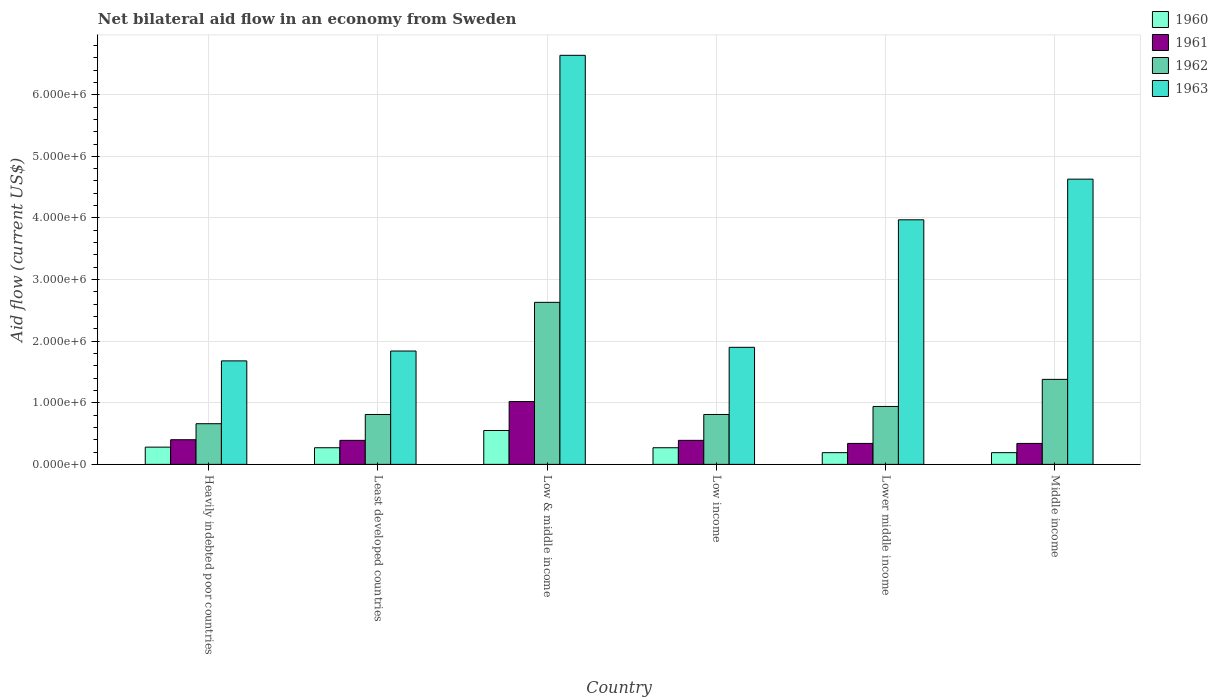How many groups of bars are there?
Ensure brevity in your answer.  6. Are the number of bars per tick equal to the number of legend labels?
Your response must be concise. Yes. How many bars are there on the 2nd tick from the left?
Keep it short and to the point. 4. What is the label of the 5th group of bars from the left?
Your response must be concise. Lower middle income. What is the net bilateral aid flow in 1962 in Low income?
Provide a succinct answer. 8.10e+05. Across all countries, what is the maximum net bilateral aid flow in 1960?
Your answer should be very brief. 5.50e+05. Across all countries, what is the minimum net bilateral aid flow in 1963?
Make the answer very short. 1.68e+06. In which country was the net bilateral aid flow in 1963 maximum?
Offer a terse response. Low & middle income. In which country was the net bilateral aid flow in 1963 minimum?
Your answer should be compact. Heavily indebted poor countries. What is the total net bilateral aid flow in 1961 in the graph?
Keep it short and to the point. 2.88e+06. What is the difference between the net bilateral aid flow in 1962 in Heavily indebted poor countries and the net bilateral aid flow in 1963 in Lower middle income?
Give a very brief answer. -3.31e+06. What is the average net bilateral aid flow in 1960 per country?
Your answer should be very brief. 2.92e+05. What is the difference between the net bilateral aid flow of/in 1962 and net bilateral aid flow of/in 1963 in Heavily indebted poor countries?
Provide a succinct answer. -1.02e+06. In how many countries, is the net bilateral aid flow in 1962 greater than 2000000 US$?
Provide a short and direct response. 1. What is the ratio of the net bilateral aid flow in 1963 in Least developed countries to that in Lower middle income?
Offer a very short reply. 0.46. What is the difference between the highest and the second highest net bilateral aid flow in 1963?
Make the answer very short. 2.01e+06. What is the difference between the highest and the lowest net bilateral aid flow in 1962?
Make the answer very short. 1.97e+06. In how many countries, is the net bilateral aid flow in 1962 greater than the average net bilateral aid flow in 1962 taken over all countries?
Make the answer very short. 2. Is the sum of the net bilateral aid flow in 1962 in Heavily indebted poor countries and Least developed countries greater than the maximum net bilateral aid flow in 1960 across all countries?
Offer a very short reply. Yes. Is it the case that in every country, the sum of the net bilateral aid flow in 1961 and net bilateral aid flow in 1962 is greater than the sum of net bilateral aid flow in 1960 and net bilateral aid flow in 1963?
Offer a terse response. No. What does the 1st bar from the right in Low & middle income represents?
Give a very brief answer. 1963. Is it the case that in every country, the sum of the net bilateral aid flow in 1961 and net bilateral aid flow in 1962 is greater than the net bilateral aid flow in 1960?
Offer a very short reply. Yes. Are all the bars in the graph horizontal?
Your answer should be very brief. No. How many countries are there in the graph?
Provide a succinct answer. 6. Does the graph contain any zero values?
Provide a succinct answer. No. Does the graph contain grids?
Offer a very short reply. Yes. How are the legend labels stacked?
Offer a very short reply. Vertical. What is the title of the graph?
Your answer should be compact. Net bilateral aid flow in an economy from Sweden. Does "1972" appear as one of the legend labels in the graph?
Offer a terse response. No. What is the label or title of the Y-axis?
Make the answer very short. Aid flow (current US$). What is the Aid flow (current US$) in 1961 in Heavily indebted poor countries?
Offer a terse response. 4.00e+05. What is the Aid flow (current US$) of 1962 in Heavily indebted poor countries?
Offer a terse response. 6.60e+05. What is the Aid flow (current US$) in 1963 in Heavily indebted poor countries?
Make the answer very short. 1.68e+06. What is the Aid flow (current US$) of 1961 in Least developed countries?
Offer a terse response. 3.90e+05. What is the Aid flow (current US$) of 1962 in Least developed countries?
Your answer should be compact. 8.10e+05. What is the Aid flow (current US$) in 1963 in Least developed countries?
Offer a very short reply. 1.84e+06. What is the Aid flow (current US$) of 1960 in Low & middle income?
Offer a very short reply. 5.50e+05. What is the Aid flow (current US$) in 1961 in Low & middle income?
Your answer should be very brief. 1.02e+06. What is the Aid flow (current US$) of 1962 in Low & middle income?
Your answer should be compact. 2.63e+06. What is the Aid flow (current US$) in 1963 in Low & middle income?
Your answer should be very brief. 6.64e+06. What is the Aid flow (current US$) in 1960 in Low income?
Provide a short and direct response. 2.70e+05. What is the Aid flow (current US$) of 1961 in Low income?
Offer a very short reply. 3.90e+05. What is the Aid flow (current US$) in 1962 in Low income?
Give a very brief answer. 8.10e+05. What is the Aid flow (current US$) of 1963 in Low income?
Keep it short and to the point. 1.90e+06. What is the Aid flow (current US$) of 1962 in Lower middle income?
Provide a short and direct response. 9.40e+05. What is the Aid flow (current US$) in 1963 in Lower middle income?
Offer a terse response. 3.97e+06. What is the Aid flow (current US$) of 1960 in Middle income?
Your answer should be compact. 1.90e+05. What is the Aid flow (current US$) in 1962 in Middle income?
Your response must be concise. 1.38e+06. What is the Aid flow (current US$) in 1963 in Middle income?
Ensure brevity in your answer.  4.63e+06. Across all countries, what is the maximum Aid flow (current US$) in 1960?
Your answer should be very brief. 5.50e+05. Across all countries, what is the maximum Aid flow (current US$) of 1961?
Give a very brief answer. 1.02e+06. Across all countries, what is the maximum Aid flow (current US$) of 1962?
Your response must be concise. 2.63e+06. Across all countries, what is the maximum Aid flow (current US$) of 1963?
Keep it short and to the point. 6.64e+06. Across all countries, what is the minimum Aid flow (current US$) of 1961?
Your answer should be compact. 3.40e+05. Across all countries, what is the minimum Aid flow (current US$) of 1963?
Your answer should be compact. 1.68e+06. What is the total Aid flow (current US$) of 1960 in the graph?
Make the answer very short. 1.75e+06. What is the total Aid flow (current US$) of 1961 in the graph?
Give a very brief answer. 2.88e+06. What is the total Aid flow (current US$) of 1962 in the graph?
Give a very brief answer. 7.23e+06. What is the total Aid flow (current US$) of 1963 in the graph?
Ensure brevity in your answer.  2.07e+07. What is the difference between the Aid flow (current US$) in 1961 in Heavily indebted poor countries and that in Low & middle income?
Ensure brevity in your answer.  -6.20e+05. What is the difference between the Aid flow (current US$) in 1962 in Heavily indebted poor countries and that in Low & middle income?
Your answer should be compact. -1.97e+06. What is the difference between the Aid flow (current US$) of 1963 in Heavily indebted poor countries and that in Low & middle income?
Your response must be concise. -4.96e+06. What is the difference between the Aid flow (current US$) of 1960 in Heavily indebted poor countries and that in Low income?
Your answer should be very brief. 10000. What is the difference between the Aid flow (current US$) of 1962 in Heavily indebted poor countries and that in Low income?
Provide a short and direct response. -1.50e+05. What is the difference between the Aid flow (current US$) in 1960 in Heavily indebted poor countries and that in Lower middle income?
Your answer should be compact. 9.00e+04. What is the difference between the Aid flow (current US$) of 1961 in Heavily indebted poor countries and that in Lower middle income?
Keep it short and to the point. 6.00e+04. What is the difference between the Aid flow (current US$) of 1962 in Heavily indebted poor countries and that in Lower middle income?
Give a very brief answer. -2.80e+05. What is the difference between the Aid flow (current US$) in 1963 in Heavily indebted poor countries and that in Lower middle income?
Your response must be concise. -2.29e+06. What is the difference between the Aid flow (current US$) of 1962 in Heavily indebted poor countries and that in Middle income?
Ensure brevity in your answer.  -7.20e+05. What is the difference between the Aid flow (current US$) of 1963 in Heavily indebted poor countries and that in Middle income?
Your answer should be compact. -2.95e+06. What is the difference between the Aid flow (current US$) in 1960 in Least developed countries and that in Low & middle income?
Make the answer very short. -2.80e+05. What is the difference between the Aid flow (current US$) in 1961 in Least developed countries and that in Low & middle income?
Keep it short and to the point. -6.30e+05. What is the difference between the Aid flow (current US$) of 1962 in Least developed countries and that in Low & middle income?
Your answer should be very brief. -1.82e+06. What is the difference between the Aid flow (current US$) of 1963 in Least developed countries and that in Low & middle income?
Your answer should be very brief. -4.80e+06. What is the difference between the Aid flow (current US$) of 1960 in Least developed countries and that in Low income?
Your answer should be compact. 0. What is the difference between the Aid flow (current US$) in 1962 in Least developed countries and that in Low income?
Keep it short and to the point. 0. What is the difference between the Aid flow (current US$) in 1963 in Least developed countries and that in Low income?
Your answer should be compact. -6.00e+04. What is the difference between the Aid flow (current US$) in 1961 in Least developed countries and that in Lower middle income?
Offer a very short reply. 5.00e+04. What is the difference between the Aid flow (current US$) of 1963 in Least developed countries and that in Lower middle income?
Provide a short and direct response. -2.13e+06. What is the difference between the Aid flow (current US$) of 1960 in Least developed countries and that in Middle income?
Offer a terse response. 8.00e+04. What is the difference between the Aid flow (current US$) in 1962 in Least developed countries and that in Middle income?
Your response must be concise. -5.70e+05. What is the difference between the Aid flow (current US$) of 1963 in Least developed countries and that in Middle income?
Offer a very short reply. -2.79e+06. What is the difference between the Aid flow (current US$) of 1961 in Low & middle income and that in Low income?
Provide a short and direct response. 6.30e+05. What is the difference between the Aid flow (current US$) in 1962 in Low & middle income and that in Low income?
Your answer should be very brief. 1.82e+06. What is the difference between the Aid flow (current US$) in 1963 in Low & middle income and that in Low income?
Offer a terse response. 4.74e+06. What is the difference between the Aid flow (current US$) of 1960 in Low & middle income and that in Lower middle income?
Offer a very short reply. 3.60e+05. What is the difference between the Aid flow (current US$) in 1961 in Low & middle income and that in Lower middle income?
Make the answer very short. 6.80e+05. What is the difference between the Aid flow (current US$) in 1962 in Low & middle income and that in Lower middle income?
Provide a short and direct response. 1.69e+06. What is the difference between the Aid flow (current US$) in 1963 in Low & middle income and that in Lower middle income?
Ensure brevity in your answer.  2.67e+06. What is the difference between the Aid flow (current US$) of 1961 in Low & middle income and that in Middle income?
Make the answer very short. 6.80e+05. What is the difference between the Aid flow (current US$) of 1962 in Low & middle income and that in Middle income?
Ensure brevity in your answer.  1.25e+06. What is the difference between the Aid flow (current US$) in 1963 in Low & middle income and that in Middle income?
Your answer should be compact. 2.01e+06. What is the difference between the Aid flow (current US$) of 1960 in Low income and that in Lower middle income?
Provide a succinct answer. 8.00e+04. What is the difference between the Aid flow (current US$) of 1962 in Low income and that in Lower middle income?
Your answer should be very brief. -1.30e+05. What is the difference between the Aid flow (current US$) in 1963 in Low income and that in Lower middle income?
Keep it short and to the point. -2.07e+06. What is the difference between the Aid flow (current US$) of 1960 in Low income and that in Middle income?
Offer a very short reply. 8.00e+04. What is the difference between the Aid flow (current US$) of 1961 in Low income and that in Middle income?
Offer a very short reply. 5.00e+04. What is the difference between the Aid flow (current US$) of 1962 in Low income and that in Middle income?
Your answer should be compact. -5.70e+05. What is the difference between the Aid flow (current US$) in 1963 in Low income and that in Middle income?
Ensure brevity in your answer.  -2.73e+06. What is the difference between the Aid flow (current US$) in 1960 in Lower middle income and that in Middle income?
Provide a short and direct response. 0. What is the difference between the Aid flow (current US$) of 1962 in Lower middle income and that in Middle income?
Your response must be concise. -4.40e+05. What is the difference between the Aid flow (current US$) of 1963 in Lower middle income and that in Middle income?
Make the answer very short. -6.60e+05. What is the difference between the Aid flow (current US$) in 1960 in Heavily indebted poor countries and the Aid flow (current US$) in 1961 in Least developed countries?
Your answer should be compact. -1.10e+05. What is the difference between the Aid flow (current US$) of 1960 in Heavily indebted poor countries and the Aid flow (current US$) of 1962 in Least developed countries?
Your response must be concise. -5.30e+05. What is the difference between the Aid flow (current US$) of 1960 in Heavily indebted poor countries and the Aid flow (current US$) of 1963 in Least developed countries?
Offer a very short reply. -1.56e+06. What is the difference between the Aid flow (current US$) of 1961 in Heavily indebted poor countries and the Aid flow (current US$) of 1962 in Least developed countries?
Your answer should be compact. -4.10e+05. What is the difference between the Aid flow (current US$) of 1961 in Heavily indebted poor countries and the Aid flow (current US$) of 1963 in Least developed countries?
Offer a terse response. -1.44e+06. What is the difference between the Aid flow (current US$) of 1962 in Heavily indebted poor countries and the Aid flow (current US$) of 1963 in Least developed countries?
Make the answer very short. -1.18e+06. What is the difference between the Aid flow (current US$) in 1960 in Heavily indebted poor countries and the Aid flow (current US$) in 1961 in Low & middle income?
Offer a very short reply. -7.40e+05. What is the difference between the Aid flow (current US$) in 1960 in Heavily indebted poor countries and the Aid flow (current US$) in 1962 in Low & middle income?
Keep it short and to the point. -2.35e+06. What is the difference between the Aid flow (current US$) in 1960 in Heavily indebted poor countries and the Aid flow (current US$) in 1963 in Low & middle income?
Provide a short and direct response. -6.36e+06. What is the difference between the Aid flow (current US$) in 1961 in Heavily indebted poor countries and the Aid flow (current US$) in 1962 in Low & middle income?
Your answer should be compact. -2.23e+06. What is the difference between the Aid flow (current US$) of 1961 in Heavily indebted poor countries and the Aid flow (current US$) of 1963 in Low & middle income?
Offer a terse response. -6.24e+06. What is the difference between the Aid flow (current US$) in 1962 in Heavily indebted poor countries and the Aid flow (current US$) in 1963 in Low & middle income?
Make the answer very short. -5.98e+06. What is the difference between the Aid flow (current US$) in 1960 in Heavily indebted poor countries and the Aid flow (current US$) in 1962 in Low income?
Give a very brief answer. -5.30e+05. What is the difference between the Aid flow (current US$) of 1960 in Heavily indebted poor countries and the Aid flow (current US$) of 1963 in Low income?
Your response must be concise. -1.62e+06. What is the difference between the Aid flow (current US$) in 1961 in Heavily indebted poor countries and the Aid flow (current US$) in 1962 in Low income?
Ensure brevity in your answer.  -4.10e+05. What is the difference between the Aid flow (current US$) of 1961 in Heavily indebted poor countries and the Aid flow (current US$) of 1963 in Low income?
Your answer should be compact. -1.50e+06. What is the difference between the Aid flow (current US$) of 1962 in Heavily indebted poor countries and the Aid flow (current US$) of 1963 in Low income?
Your answer should be compact. -1.24e+06. What is the difference between the Aid flow (current US$) of 1960 in Heavily indebted poor countries and the Aid flow (current US$) of 1962 in Lower middle income?
Ensure brevity in your answer.  -6.60e+05. What is the difference between the Aid flow (current US$) of 1960 in Heavily indebted poor countries and the Aid flow (current US$) of 1963 in Lower middle income?
Provide a succinct answer. -3.69e+06. What is the difference between the Aid flow (current US$) in 1961 in Heavily indebted poor countries and the Aid flow (current US$) in 1962 in Lower middle income?
Give a very brief answer. -5.40e+05. What is the difference between the Aid flow (current US$) of 1961 in Heavily indebted poor countries and the Aid flow (current US$) of 1963 in Lower middle income?
Give a very brief answer. -3.57e+06. What is the difference between the Aid flow (current US$) in 1962 in Heavily indebted poor countries and the Aid flow (current US$) in 1963 in Lower middle income?
Your answer should be very brief. -3.31e+06. What is the difference between the Aid flow (current US$) in 1960 in Heavily indebted poor countries and the Aid flow (current US$) in 1962 in Middle income?
Offer a terse response. -1.10e+06. What is the difference between the Aid flow (current US$) in 1960 in Heavily indebted poor countries and the Aid flow (current US$) in 1963 in Middle income?
Provide a short and direct response. -4.35e+06. What is the difference between the Aid flow (current US$) in 1961 in Heavily indebted poor countries and the Aid flow (current US$) in 1962 in Middle income?
Keep it short and to the point. -9.80e+05. What is the difference between the Aid flow (current US$) of 1961 in Heavily indebted poor countries and the Aid flow (current US$) of 1963 in Middle income?
Offer a very short reply. -4.23e+06. What is the difference between the Aid flow (current US$) of 1962 in Heavily indebted poor countries and the Aid flow (current US$) of 1963 in Middle income?
Provide a short and direct response. -3.97e+06. What is the difference between the Aid flow (current US$) of 1960 in Least developed countries and the Aid flow (current US$) of 1961 in Low & middle income?
Provide a succinct answer. -7.50e+05. What is the difference between the Aid flow (current US$) in 1960 in Least developed countries and the Aid flow (current US$) in 1962 in Low & middle income?
Your answer should be very brief. -2.36e+06. What is the difference between the Aid flow (current US$) in 1960 in Least developed countries and the Aid flow (current US$) in 1963 in Low & middle income?
Your answer should be very brief. -6.37e+06. What is the difference between the Aid flow (current US$) in 1961 in Least developed countries and the Aid flow (current US$) in 1962 in Low & middle income?
Keep it short and to the point. -2.24e+06. What is the difference between the Aid flow (current US$) in 1961 in Least developed countries and the Aid flow (current US$) in 1963 in Low & middle income?
Give a very brief answer. -6.25e+06. What is the difference between the Aid flow (current US$) in 1962 in Least developed countries and the Aid flow (current US$) in 1963 in Low & middle income?
Your answer should be compact. -5.83e+06. What is the difference between the Aid flow (current US$) of 1960 in Least developed countries and the Aid flow (current US$) of 1962 in Low income?
Make the answer very short. -5.40e+05. What is the difference between the Aid flow (current US$) of 1960 in Least developed countries and the Aid flow (current US$) of 1963 in Low income?
Ensure brevity in your answer.  -1.63e+06. What is the difference between the Aid flow (current US$) of 1961 in Least developed countries and the Aid flow (current US$) of 1962 in Low income?
Provide a short and direct response. -4.20e+05. What is the difference between the Aid flow (current US$) in 1961 in Least developed countries and the Aid flow (current US$) in 1963 in Low income?
Your answer should be compact. -1.51e+06. What is the difference between the Aid flow (current US$) in 1962 in Least developed countries and the Aid flow (current US$) in 1963 in Low income?
Ensure brevity in your answer.  -1.09e+06. What is the difference between the Aid flow (current US$) in 1960 in Least developed countries and the Aid flow (current US$) in 1961 in Lower middle income?
Your answer should be compact. -7.00e+04. What is the difference between the Aid flow (current US$) of 1960 in Least developed countries and the Aid flow (current US$) of 1962 in Lower middle income?
Provide a succinct answer. -6.70e+05. What is the difference between the Aid flow (current US$) in 1960 in Least developed countries and the Aid flow (current US$) in 1963 in Lower middle income?
Ensure brevity in your answer.  -3.70e+06. What is the difference between the Aid flow (current US$) of 1961 in Least developed countries and the Aid flow (current US$) of 1962 in Lower middle income?
Ensure brevity in your answer.  -5.50e+05. What is the difference between the Aid flow (current US$) in 1961 in Least developed countries and the Aid flow (current US$) in 1963 in Lower middle income?
Offer a very short reply. -3.58e+06. What is the difference between the Aid flow (current US$) in 1962 in Least developed countries and the Aid flow (current US$) in 1963 in Lower middle income?
Your answer should be very brief. -3.16e+06. What is the difference between the Aid flow (current US$) in 1960 in Least developed countries and the Aid flow (current US$) in 1962 in Middle income?
Your answer should be very brief. -1.11e+06. What is the difference between the Aid flow (current US$) of 1960 in Least developed countries and the Aid flow (current US$) of 1963 in Middle income?
Give a very brief answer. -4.36e+06. What is the difference between the Aid flow (current US$) in 1961 in Least developed countries and the Aid flow (current US$) in 1962 in Middle income?
Make the answer very short. -9.90e+05. What is the difference between the Aid flow (current US$) of 1961 in Least developed countries and the Aid flow (current US$) of 1963 in Middle income?
Keep it short and to the point. -4.24e+06. What is the difference between the Aid flow (current US$) of 1962 in Least developed countries and the Aid flow (current US$) of 1963 in Middle income?
Your answer should be very brief. -3.82e+06. What is the difference between the Aid flow (current US$) in 1960 in Low & middle income and the Aid flow (current US$) in 1962 in Low income?
Make the answer very short. -2.60e+05. What is the difference between the Aid flow (current US$) of 1960 in Low & middle income and the Aid flow (current US$) of 1963 in Low income?
Your answer should be very brief. -1.35e+06. What is the difference between the Aid flow (current US$) in 1961 in Low & middle income and the Aid flow (current US$) in 1963 in Low income?
Make the answer very short. -8.80e+05. What is the difference between the Aid flow (current US$) in 1962 in Low & middle income and the Aid flow (current US$) in 1963 in Low income?
Your response must be concise. 7.30e+05. What is the difference between the Aid flow (current US$) of 1960 in Low & middle income and the Aid flow (current US$) of 1961 in Lower middle income?
Offer a terse response. 2.10e+05. What is the difference between the Aid flow (current US$) of 1960 in Low & middle income and the Aid flow (current US$) of 1962 in Lower middle income?
Provide a succinct answer. -3.90e+05. What is the difference between the Aid flow (current US$) in 1960 in Low & middle income and the Aid flow (current US$) in 1963 in Lower middle income?
Provide a succinct answer. -3.42e+06. What is the difference between the Aid flow (current US$) of 1961 in Low & middle income and the Aid flow (current US$) of 1962 in Lower middle income?
Your answer should be very brief. 8.00e+04. What is the difference between the Aid flow (current US$) of 1961 in Low & middle income and the Aid flow (current US$) of 1963 in Lower middle income?
Ensure brevity in your answer.  -2.95e+06. What is the difference between the Aid flow (current US$) of 1962 in Low & middle income and the Aid flow (current US$) of 1963 in Lower middle income?
Provide a short and direct response. -1.34e+06. What is the difference between the Aid flow (current US$) of 1960 in Low & middle income and the Aid flow (current US$) of 1962 in Middle income?
Your response must be concise. -8.30e+05. What is the difference between the Aid flow (current US$) in 1960 in Low & middle income and the Aid flow (current US$) in 1963 in Middle income?
Provide a short and direct response. -4.08e+06. What is the difference between the Aid flow (current US$) of 1961 in Low & middle income and the Aid flow (current US$) of 1962 in Middle income?
Give a very brief answer. -3.60e+05. What is the difference between the Aid flow (current US$) of 1961 in Low & middle income and the Aid flow (current US$) of 1963 in Middle income?
Keep it short and to the point. -3.61e+06. What is the difference between the Aid flow (current US$) of 1960 in Low income and the Aid flow (current US$) of 1962 in Lower middle income?
Make the answer very short. -6.70e+05. What is the difference between the Aid flow (current US$) of 1960 in Low income and the Aid flow (current US$) of 1963 in Lower middle income?
Provide a short and direct response. -3.70e+06. What is the difference between the Aid flow (current US$) in 1961 in Low income and the Aid flow (current US$) in 1962 in Lower middle income?
Offer a terse response. -5.50e+05. What is the difference between the Aid flow (current US$) in 1961 in Low income and the Aid flow (current US$) in 1963 in Lower middle income?
Provide a short and direct response. -3.58e+06. What is the difference between the Aid flow (current US$) in 1962 in Low income and the Aid flow (current US$) in 1963 in Lower middle income?
Your answer should be compact. -3.16e+06. What is the difference between the Aid flow (current US$) of 1960 in Low income and the Aid flow (current US$) of 1962 in Middle income?
Your response must be concise. -1.11e+06. What is the difference between the Aid flow (current US$) of 1960 in Low income and the Aid flow (current US$) of 1963 in Middle income?
Your answer should be compact. -4.36e+06. What is the difference between the Aid flow (current US$) in 1961 in Low income and the Aid flow (current US$) in 1962 in Middle income?
Your answer should be very brief. -9.90e+05. What is the difference between the Aid flow (current US$) in 1961 in Low income and the Aid flow (current US$) in 1963 in Middle income?
Offer a very short reply. -4.24e+06. What is the difference between the Aid flow (current US$) of 1962 in Low income and the Aid flow (current US$) of 1963 in Middle income?
Ensure brevity in your answer.  -3.82e+06. What is the difference between the Aid flow (current US$) of 1960 in Lower middle income and the Aid flow (current US$) of 1961 in Middle income?
Your answer should be very brief. -1.50e+05. What is the difference between the Aid flow (current US$) of 1960 in Lower middle income and the Aid flow (current US$) of 1962 in Middle income?
Your answer should be very brief. -1.19e+06. What is the difference between the Aid flow (current US$) in 1960 in Lower middle income and the Aid flow (current US$) in 1963 in Middle income?
Your answer should be very brief. -4.44e+06. What is the difference between the Aid flow (current US$) of 1961 in Lower middle income and the Aid flow (current US$) of 1962 in Middle income?
Ensure brevity in your answer.  -1.04e+06. What is the difference between the Aid flow (current US$) in 1961 in Lower middle income and the Aid flow (current US$) in 1963 in Middle income?
Your answer should be very brief. -4.29e+06. What is the difference between the Aid flow (current US$) of 1962 in Lower middle income and the Aid flow (current US$) of 1963 in Middle income?
Your answer should be very brief. -3.69e+06. What is the average Aid flow (current US$) of 1960 per country?
Your response must be concise. 2.92e+05. What is the average Aid flow (current US$) in 1961 per country?
Your response must be concise. 4.80e+05. What is the average Aid flow (current US$) in 1962 per country?
Your answer should be compact. 1.20e+06. What is the average Aid flow (current US$) of 1963 per country?
Provide a succinct answer. 3.44e+06. What is the difference between the Aid flow (current US$) of 1960 and Aid flow (current US$) of 1961 in Heavily indebted poor countries?
Provide a short and direct response. -1.20e+05. What is the difference between the Aid flow (current US$) of 1960 and Aid flow (current US$) of 1962 in Heavily indebted poor countries?
Offer a very short reply. -3.80e+05. What is the difference between the Aid flow (current US$) in 1960 and Aid flow (current US$) in 1963 in Heavily indebted poor countries?
Your answer should be very brief. -1.40e+06. What is the difference between the Aid flow (current US$) of 1961 and Aid flow (current US$) of 1963 in Heavily indebted poor countries?
Keep it short and to the point. -1.28e+06. What is the difference between the Aid flow (current US$) of 1962 and Aid flow (current US$) of 1963 in Heavily indebted poor countries?
Your answer should be very brief. -1.02e+06. What is the difference between the Aid flow (current US$) in 1960 and Aid flow (current US$) in 1962 in Least developed countries?
Your answer should be compact. -5.40e+05. What is the difference between the Aid flow (current US$) in 1960 and Aid flow (current US$) in 1963 in Least developed countries?
Ensure brevity in your answer.  -1.57e+06. What is the difference between the Aid flow (current US$) of 1961 and Aid flow (current US$) of 1962 in Least developed countries?
Offer a terse response. -4.20e+05. What is the difference between the Aid flow (current US$) of 1961 and Aid flow (current US$) of 1963 in Least developed countries?
Your answer should be very brief. -1.45e+06. What is the difference between the Aid flow (current US$) of 1962 and Aid flow (current US$) of 1963 in Least developed countries?
Your answer should be compact. -1.03e+06. What is the difference between the Aid flow (current US$) in 1960 and Aid flow (current US$) in 1961 in Low & middle income?
Offer a terse response. -4.70e+05. What is the difference between the Aid flow (current US$) in 1960 and Aid flow (current US$) in 1962 in Low & middle income?
Make the answer very short. -2.08e+06. What is the difference between the Aid flow (current US$) in 1960 and Aid flow (current US$) in 1963 in Low & middle income?
Give a very brief answer. -6.09e+06. What is the difference between the Aid flow (current US$) in 1961 and Aid flow (current US$) in 1962 in Low & middle income?
Provide a succinct answer. -1.61e+06. What is the difference between the Aid flow (current US$) in 1961 and Aid flow (current US$) in 1963 in Low & middle income?
Ensure brevity in your answer.  -5.62e+06. What is the difference between the Aid flow (current US$) of 1962 and Aid flow (current US$) of 1963 in Low & middle income?
Provide a short and direct response. -4.01e+06. What is the difference between the Aid flow (current US$) of 1960 and Aid flow (current US$) of 1962 in Low income?
Give a very brief answer. -5.40e+05. What is the difference between the Aid flow (current US$) in 1960 and Aid flow (current US$) in 1963 in Low income?
Offer a terse response. -1.63e+06. What is the difference between the Aid flow (current US$) of 1961 and Aid flow (current US$) of 1962 in Low income?
Give a very brief answer. -4.20e+05. What is the difference between the Aid flow (current US$) in 1961 and Aid flow (current US$) in 1963 in Low income?
Offer a very short reply. -1.51e+06. What is the difference between the Aid flow (current US$) of 1962 and Aid flow (current US$) of 1963 in Low income?
Provide a short and direct response. -1.09e+06. What is the difference between the Aid flow (current US$) of 1960 and Aid flow (current US$) of 1962 in Lower middle income?
Ensure brevity in your answer.  -7.50e+05. What is the difference between the Aid flow (current US$) of 1960 and Aid flow (current US$) of 1963 in Lower middle income?
Offer a very short reply. -3.78e+06. What is the difference between the Aid flow (current US$) in 1961 and Aid flow (current US$) in 1962 in Lower middle income?
Your response must be concise. -6.00e+05. What is the difference between the Aid flow (current US$) of 1961 and Aid flow (current US$) of 1963 in Lower middle income?
Ensure brevity in your answer.  -3.63e+06. What is the difference between the Aid flow (current US$) in 1962 and Aid flow (current US$) in 1963 in Lower middle income?
Offer a very short reply. -3.03e+06. What is the difference between the Aid flow (current US$) in 1960 and Aid flow (current US$) in 1961 in Middle income?
Make the answer very short. -1.50e+05. What is the difference between the Aid flow (current US$) in 1960 and Aid flow (current US$) in 1962 in Middle income?
Offer a very short reply. -1.19e+06. What is the difference between the Aid flow (current US$) in 1960 and Aid flow (current US$) in 1963 in Middle income?
Ensure brevity in your answer.  -4.44e+06. What is the difference between the Aid flow (current US$) in 1961 and Aid flow (current US$) in 1962 in Middle income?
Make the answer very short. -1.04e+06. What is the difference between the Aid flow (current US$) in 1961 and Aid flow (current US$) in 1963 in Middle income?
Provide a short and direct response. -4.29e+06. What is the difference between the Aid flow (current US$) in 1962 and Aid flow (current US$) in 1963 in Middle income?
Give a very brief answer. -3.25e+06. What is the ratio of the Aid flow (current US$) of 1960 in Heavily indebted poor countries to that in Least developed countries?
Provide a succinct answer. 1.04. What is the ratio of the Aid flow (current US$) in 1961 in Heavily indebted poor countries to that in Least developed countries?
Keep it short and to the point. 1.03. What is the ratio of the Aid flow (current US$) of 1962 in Heavily indebted poor countries to that in Least developed countries?
Ensure brevity in your answer.  0.81. What is the ratio of the Aid flow (current US$) in 1960 in Heavily indebted poor countries to that in Low & middle income?
Make the answer very short. 0.51. What is the ratio of the Aid flow (current US$) in 1961 in Heavily indebted poor countries to that in Low & middle income?
Provide a short and direct response. 0.39. What is the ratio of the Aid flow (current US$) of 1962 in Heavily indebted poor countries to that in Low & middle income?
Provide a short and direct response. 0.25. What is the ratio of the Aid flow (current US$) of 1963 in Heavily indebted poor countries to that in Low & middle income?
Provide a short and direct response. 0.25. What is the ratio of the Aid flow (current US$) in 1961 in Heavily indebted poor countries to that in Low income?
Give a very brief answer. 1.03. What is the ratio of the Aid flow (current US$) in 1962 in Heavily indebted poor countries to that in Low income?
Provide a short and direct response. 0.81. What is the ratio of the Aid flow (current US$) of 1963 in Heavily indebted poor countries to that in Low income?
Offer a terse response. 0.88. What is the ratio of the Aid flow (current US$) in 1960 in Heavily indebted poor countries to that in Lower middle income?
Your response must be concise. 1.47. What is the ratio of the Aid flow (current US$) of 1961 in Heavily indebted poor countries to that in Lower middle income?
Offer a very short reply. 1.18. What is the ratio of the Aid flow (current US$) in 1962 in Heavily indebted poor countries to that in Lower middle income?
Keep it short and to the point. 0.7. What is the ratio of the Aid flow (current US$) in 1963 in Heavily indebted poor countries to that in Lower middle income?
Your answer should be very brief. 0.42. What is the ratio of the Aid flow (current US$) in 1960 in Heavily indebted poor countries to that in Middle income?
Give a very brief answer. 1.47. What is the ratio of the Aid flow (current US$) of 1961 in Heavily indebted poor countries to that in Middle income?
Your answer should be very brief. 1.18. What is the ratio of the Aid flow (current US$) in 1962 in Heavily indebted poor countries to that in Middle income?
Your answer should be very brief. 0.48. What is the ratio of the Aid flow (current US$) in 1963 in Heavily indebted poor countries to that in Middle income?
Your answer should be compact. 0.36. What is the ratio of the Aid flow (current US$) of 1960 in Least developed countries to that in Low & middle income?
Give a very brief answer. 0.49. What is the ratio of the Aid flow (current US$) of 1961 in Least developed countries to that in Low & middle income?
Give a very brief answer. 0.38. What is the ratio of the Aid flow (current US$) in 1962 in Least developed countries to that in Low & middle income?
Your answer should be compact. 0.31. What is the ratio of the Aid flow (current US$) of 1963 in Least developed countries to that in Low & middle income?
Your answer should be compact. 0.28. What is the ratio of the Aid flow (current US$) in 1961 in Least developed countries to that in Low income?
Provide a succinct answer. 1. What is the ratio of the Aid flow (current US$) in 1963 in Least developed countries to that in Low income?
Keep it short and to the point. 0.97. What is the ratio of the Aid flow (current US$) of 1960 in Least developed countries to that in Lower middle income?
Provide a short and direct response. 1.42. What is the ratio of the Aid flow (current US$) in 1961 in Least developed countries to that in Lower middle income?
Keep it short and to the point. 1.15. What is the ratio of the Aid flow (current US$) of 1962 in Least developed countries to that in Lower middle income?
Ensure brevity in your answer.  0.86. What is the ratio of the Aid flow (current US$) in 1963 in Least developed countries to that in Lower middle income?
Offer a very short reply. 0.46. What is the ratio of the Aid flow (current US$) in 1960 in Least developed countries to that in Middle income?
Ensure brevity in your answer.  1.42. What is the ratio of the Aid flow (current US$) of 1961 in Least developed countries to that in Middle income?
Offer a very short reply. 1.15. What is the ratio of the Aid flow (current US$) of 1962 in Least developed countries to that in Middle income?
Give a very brief answer. 0.59. What is the ratio of the Aid flow (current US$) in 1963 in Least developed countries to that in Middle income?
Your response must be concise. 0.4. What is the ratio of the Aid flow (current US$) of 1960 in Low & middle income to that in Low income?
Ensure brevity in your answer.  2.04. What is the ratio of the Aid flow (current US$) in 1961 in Low & middle income to that in Low income?
Offer a terse response. 2.62. What is the ratio of the Aid flow (current US$) in 1962 in Low & middle income to that in Low income?
Your response must be concise. 3.25. What is the ratio of the Aid flow (current US$) of 1963 in Low & middle income to that in Low income?
Give a very brief answer. 3.49. What is the ratio of the Aid flow (current US$) in 1960 in Low & middle income to that in Lower middle income?
Your answer should be compact. 2.89. What is the ratio of the Aid flow (current US$) of 1962 in Low & middle income to that in Lower middle income?
Provide a short and direct response. 2.8. What is the ratio of the Aid flow (current US$) of 1963 in Low & middle income to that in Lower middle income?
Provide a short and direct response. 1.67. What is the ratio of the Aid flow (current US$) of 1960 in Low & middle income to that in Middle income?
Offer a terse response. 2.89. What is the ratio of the Aid flow (current US$) of 1962 in Low & middle income to that in Middle income?
Your response must be concise. 1.91. What is the ratio of the Aid flow (current US$) of 1963 in Low & middle income to that in Middle income?
Provide a short and direct response. 1.43. What is the ratio of the Aid flow (current US$) of 1960 in Low income to that in Lower middle income?
Offer a very short reply. 1.42. What is the ratio of the Aid flow (current US$) of 1961 in Low income to that in Lower middle income?
Your response must be concise. 1.15. What is the ratio of the Aid flow (current US$) in 1962 in Low income to that in Lower middle income?
Your answer should be very brief. 0.86. What is the ratio of the Aid flow (current US$) of 1963 in Low income to that in Lower middle income?
Provide a succinct answer. 0.48. What is the ratio of the Aid flow (current US$) in 1960 in Low income to that in Middle income?
Give a very brief answer. 1.42. What is the ratio of the Aid flow (current US$) in 1961 in Low income to that in Middle income?
Ensure brevity in your answer.  1.15. What is the ratio of the Aid flow (current US$) of 1962 in Low income to that in Middle income?
Keep it short and to the point. 0.59. What is the ratio of the Aid flow (current US$) in 1963 in Low income to that in Middle income?
Provide a succinct answer. 0.41. What is the ratio of the Aid flow (current US$) of 1962 in Lower middle income to that in Middle income?
Keep it short and to the point. 0.68. What is the ratio of the Aid flow (current US$) of 1963 in Lower middle income to that in Middle income?
Keep it short and to the point. 0.86. What is the difference between the highest and the second highest Aid flow (current US$) in 1961?
Provide a short and direct response. 6.20e+05. What is the difference between the highest and the second highest Aid flow (current US$) of 1962?
Ensure brevity in your answer.  1.25e+06. What is the difference between the highest and the second highest Aid flow (current US$) of 1963?
Provide a short and direct response. 2.01e+06. What is the difference between the highest and the lowest Aid flow (current US$) of 1960?
Your response must be concise. 3.60e+05. What is the difference between the highest and the lowest Aid flow (current US$) in 1961?
Your answer should be compact. 6.80e+05. What is the difference between the highest and the lowest Aid flow (current US$) in 1962?
Your response must be concise. 1.97e+06. What is the difference between the highest and the lowest Aid flow (current US$) of 1963?
Give a very brief answer. 4.96e+06. 